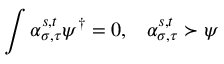<formula> <loc_0><loc_0><loc_500><loc_500>\int \alpha _ { \sigma , \tau } ^ { s , t } \psi ^ { \dagger } = 0 , \, \alpha _ { \sigma , \tau } ^ { s , t } \succ \psi</formula> 